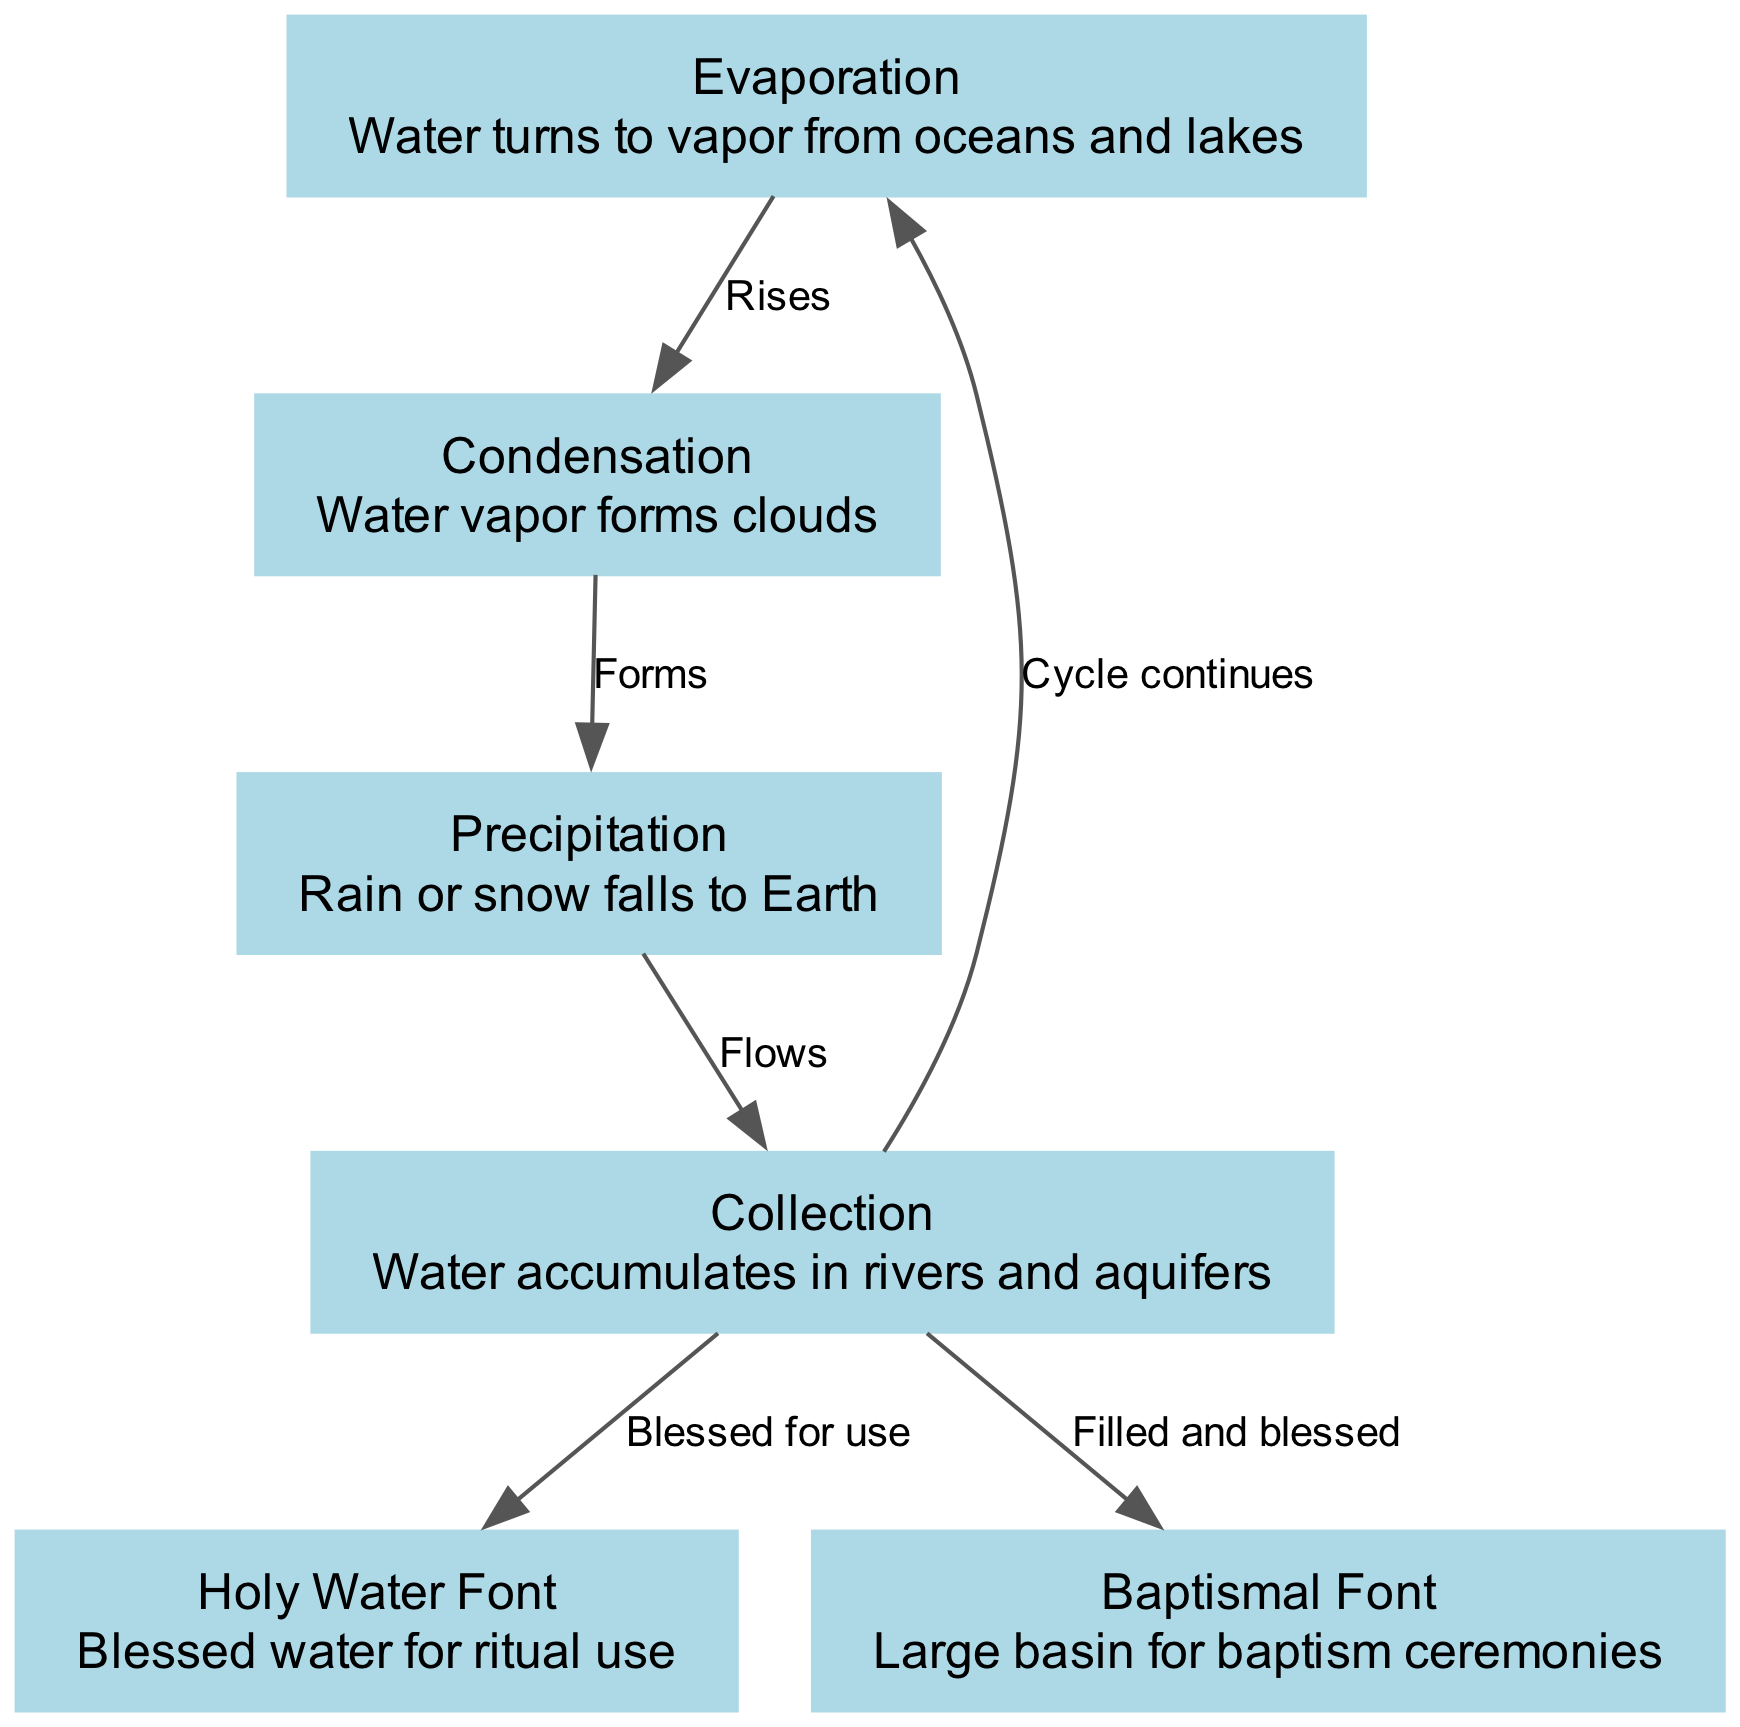What are the four main processes in the water cycle? The diagram lists four main processes: Evaporation, Condensation, Precipitation, and Collection. These are the key stages showing how water circulates in the environment.
Answer: Evaporation, Condensation, Precipitation, Collection How many nodes are related to holy water? There are two nodes related to holy water in the diagram: Holy Water Font and Baptismal Font. These nodes represent the use of blessed water in church rituals.
Answer: 2 What flows from Precipitation to Collection? The edge labeled "Flows" indicates the movement from the Precipitation node to the Collection node, showing the process of water collecting in bodies like rivers.
Answer: Collection Which node is directly blessed for church use? The edge labeled "Blessed for use" connects the Collection node to the Holy Water Font, indicating that this source of water is specifically blessed for ritualistic practices.
Answer: Holy Water Font What is the last step of the water cycle according to the diagram? The final step is indicated by the edge labeled "Cycle continues," leading from Collection back to Evaporation, highlighting the cyclical nature of the water cycle.
Answer: Evaporation Where do the baptism ceremonies take place according to the diagram? The Baptismal Font node specifies the large basin designated for performing baptism ceremonies, indicating its importance in the context of holy water usage.
Answer: Baptismal Font Which node follows Condensation? According to the diagram, Condensation is followed by the Precipitation node, as denoted by the edge labeled "Forms," showing the sequential flow of the water cycle.
Answer: Precipitation What accumulates in rivers and aquifers? The Collection node describes the accumulation of water that takes place in rivers and aquifers after precipitation, capturing the essence of water storage in natural systems.
Answer: Water 